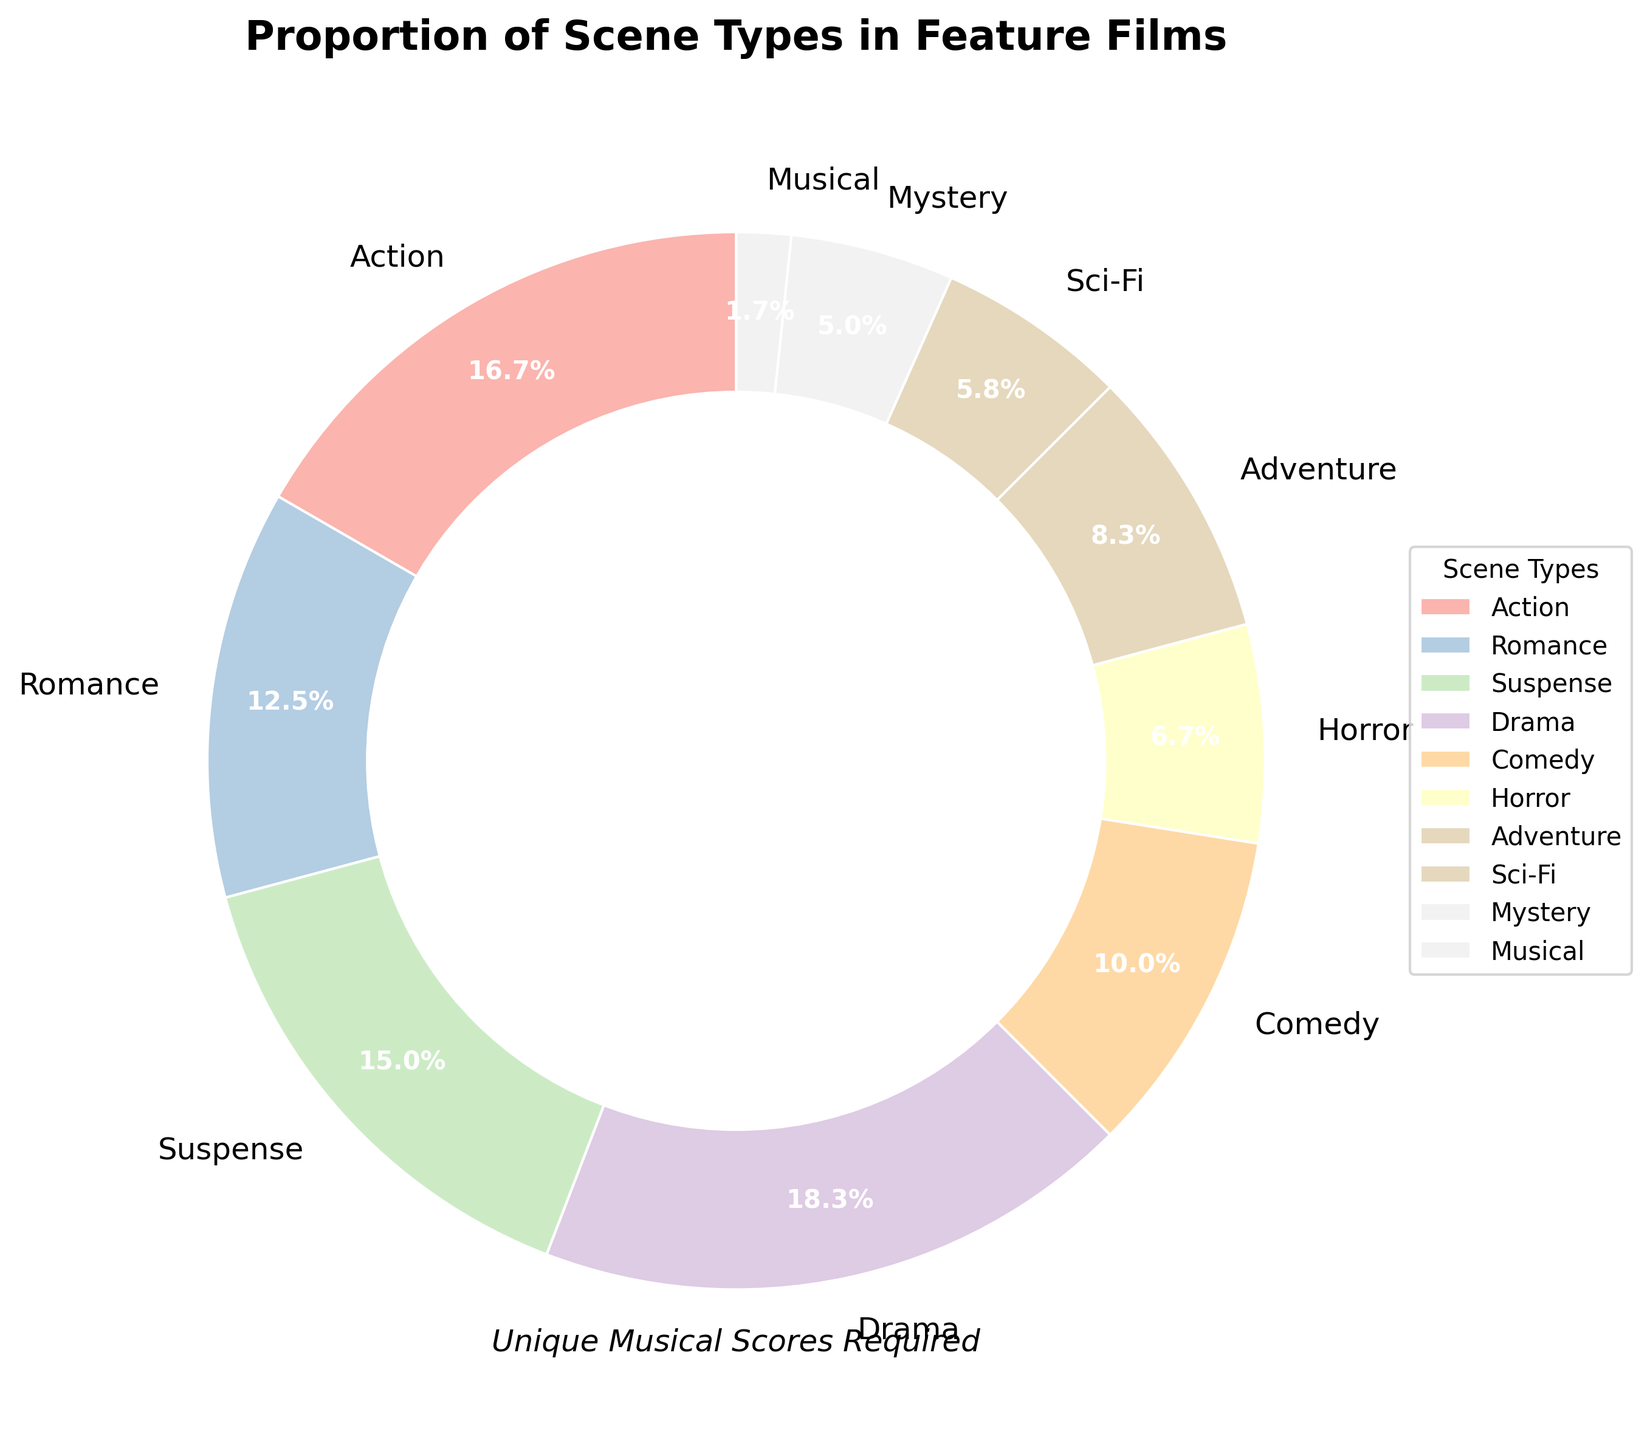Which scene type has the largest proportion? The largest wedge in the pie chart corresponds to the Drama scene type, which has the highest percentage.
Answer: Drama Which scene type has the smallest proportion? The smallest wedge in the pie chart corresponds to the Musical scene type, which has the lowest percentage.
Answer: Musical How much larger is the proportion of Action scenes compared to Sci-Fi scenes? Action scenes make up 20% while Sci-Fi scenes make up 7%. The difference is 20% - 7%.
Answer: 13% What is the combined percentage of Romance and Comedy scenes? The pie chart shows Romance as 15% and Comedy as 12%. Their combined percentage is 15% + 12%.
Answer: 27% Is the percentage of Horror scenes more or less than the percentage of Adventure scenes? The pie chart shows Horror scenes at 8% and Adventure scenes at 10%. Horror is less than Adventure.
Answer: Less What scene types make up a total of 40% of the film? Looking for scene types whose percentages sum to 40%. Action (20%) + Romance (15%) + Musical (2%) + Mystery (3%) = 40%.
Answer: Action, Romance, Musical, Mystery What is the average percentage of scenes that are Drama, Suspense, and Horror? Drama is 22%, Suspense is 18%, and Horror is 8%. The average is (22 + 18 + 8)/3.
Answer: 16% Which scene type appears the second most frequently? The second largest wedge in the pie chart represents the Action scene type, at 20%.
Answer: Action How does the proportion of Suspense scenes compare to Adventure scenes? Suspense is 18% and Adventure is 10%. Suspense is more than Adventure.
Answer: More What is the total percentage of all scene types that require unique musical scores under 10%? From the pie chart: Horror (8%), Sci-Fi (7%), Mystery (6%), Musical (2%). Total percentage is 8% + 7% + 6% + 2%.
Answer: 23% 